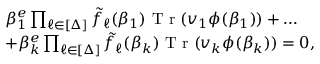Convert formula to latex. <formula><loc_0><loc_0><loc_500><loc_500>\begin{array} { r l } & { \beta _ { 1 } ^ { e } \prod _ { \ell \in [ \Delta ] } \tilde { f } _ { \ell } ( \beta _ { 1 } ) T r ( v _ { 1 } \phi ( \beta _ { 1 } ) ) + \dots } \\ & { + \beta _ { k } ^ { e } \prod _ { \ell \in [ \Delta ] } \tilde { f } _ { \ell } ( \beta _ { k } ) T r ( v _ { k } \phi ( \beta _ { k } ) ) = 0 , } \end{array}</formula> 